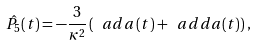Convert formula to latex. <formula><loc_0><loc_0><loc_500><loc_500>\hat { P _ { 5 } } ( t ) = - \frac { 3 } { \kappa ^ { 2 } } \left ( \ a d a \, ( t ) + \ a d d a ( t ) \right ) ,</formula> 